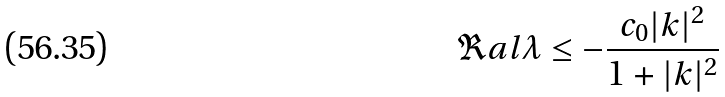Convert formula to latex. <formula><loc_0><loc_0><loc_500><loc_500>\Re a l \lambda \leq - \frac { c _ { 0 } | k | ^ { 2 } } { 1 + | k | ^ { 2 } }</formula> 